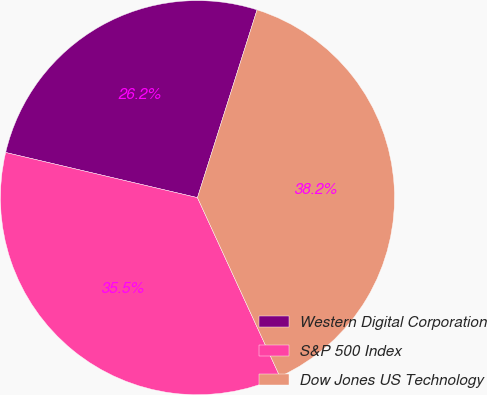<chart> <loc_0><loc_0><loc_500><loc_500><pie_chart><fcel>Western Digital Corporation<fcel>S&P 500 Index<fcel>Dow Jones US Technology<nl><fcel>26.21%<fcel>35.55%<fcel>38.24%<nl></chart> 